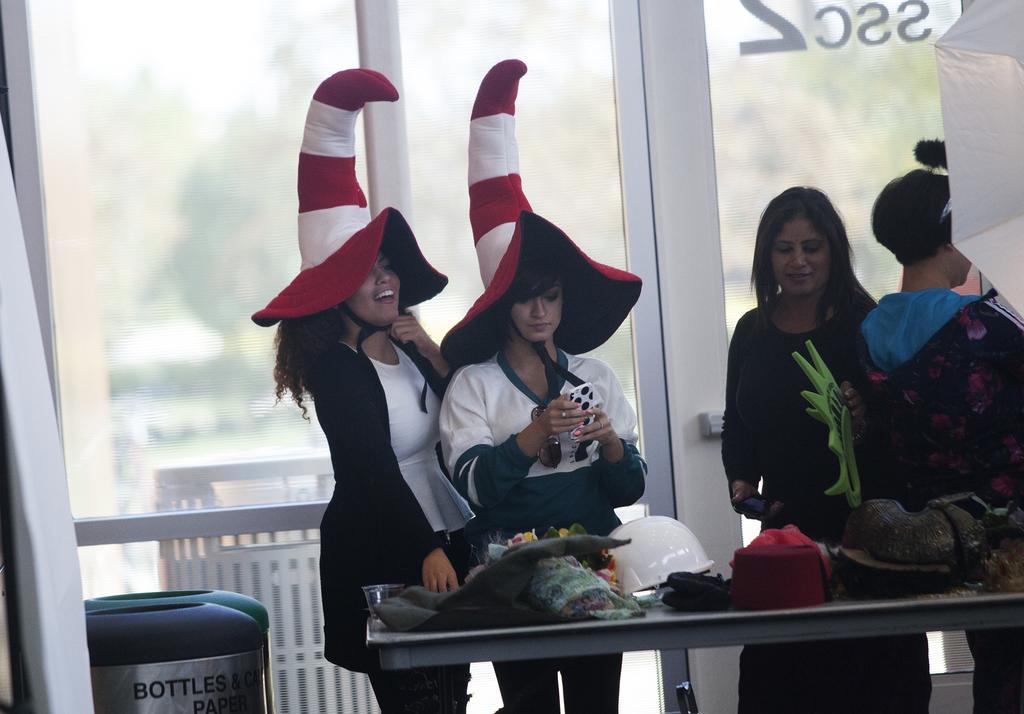Could you give a brief overview of what you see in this image? In this image there are group of people standing together wearing drama costumes, in front of them there is a table with so many things, behind them there is a glass wall, also there are few dustbins beside them. 